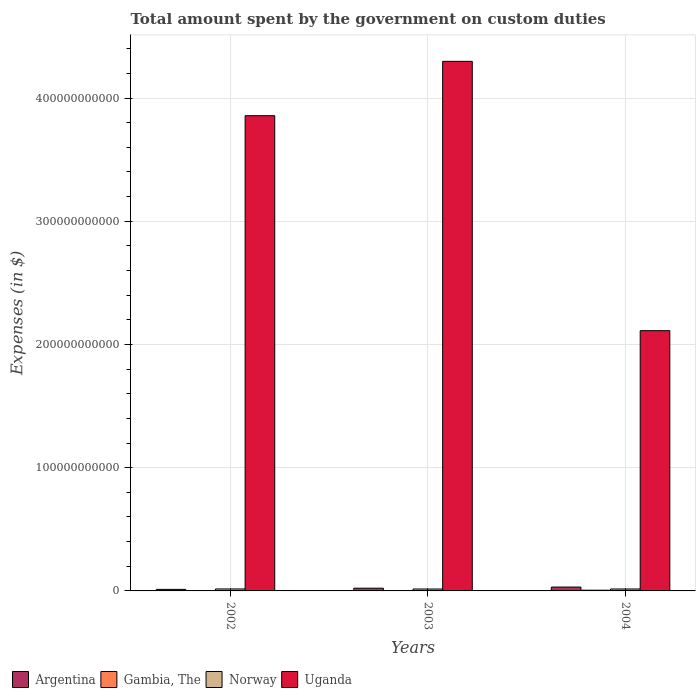How many groups of bars are there?
Your response must be concise. 3. Are the number of bars on each tick of the X-axis equal?
Your answer should be very brief. Yes. What is the amount spent on custom duties by the government in Uganda in 2002?
Ensure brevity in your answer.  3.86e+11. Across all years, what is the maximum amount spent on custom duties by the government in Gambia, The?
Your response must be concise. 5.77e+08. Across all years, what is the minimum amount spent on custom duties by the government in Uganda?
Offer a terse response. 2.11e+11. In which year was the amount spent on custom duties by the government in Gambia, The maximum?
Make the answer very short. 2004. In which year was the amount spent on custom duties by the government in Norway minimum?
Offer a terse response. 2003. What is the total amount spent on custom duties by the government in Gambia, The in the graph?
Give a very brief answer. 1.10e+09. What is the difference between the amount spent on custom duties by the government in Gambia, The in 2002 and that in 2004?
Provide a short and direct response. -3.51e+08. What is the difference between the amount spent on custom duties by the government in Norway in 2003 and the amount spent on custom duties by the government in Argentina in 2004?
Ensure brevity in your answer.  -1.58e+09. What is the average amount spent on custom duties by the government in Uganda per year?
Offer a very short reply. 3.42e+11. In the year 2002, what is the difference between the amount spent on custom duties by the government in Gambia, The and amount spent on custom duties by the government in Argentina?
Provide a short and direct response. -1.02e+09. In how many years, is the amount spent on custom duties by the government in Uganda greater than 160000000000 $?
Your answer should be very brief. 3. What is the ratio of the amount spent on custom duties by the government in Argentina in 2002 to that in 2004?
Your answer should be compact. 0.4. Is the amount spent on custom duties by the government in Uganda in 2003 less than that in 2004?
Keep it short and to the point. No. Is the difference between the amount spent on custom duties by the government in Gambia, The in 2003 and 2004 greater than the difference between the amount spent on custom duties by the government in Argentina in 2003 and 2004?
Offer a very short reply. Yes. What is the difference between the highest and the second highest amount spent on custom duties by the government in Gambia, The?
Keep it short and to the point. 2.86e+08. What is the difference between the highest and the lowest amount spent on custom duties by the government in Uganda?
Your answer should be compact. 2.19e+11. In how many years, is the amount spent on custom duties by the government in Norway greater than the average amount spent on custom duties by the government in Norway taken over all years?
Provide a short and direct response. 1. Is it the case that in every year, the sum of the amount spent on custom duties by the government in Gambia, The and amount spent on custom duties by the government in Uganda is greater than the sum of amount spent on custom duties by the government in Argentina and amount spent on custom duties by the government in Norway?
Provide a succinct answer. Yes. What does the 4th bar from the left in 2004 represents?
Keep it short and to the point. Uganda. What does the 1st bar from the right in 2002 represents?
Your answer should be very brief. Uganda. Is it the case that in every year, the sum of the amount spent on custom duties by the government in Gambia, The and amount spent on custom duties by the government in Argentina is greater than the amount spent on custom duties by the government in Norway?
Your answer should be very brief. No. How many bars are there?
Offer a terse response. 12. Are all the bars in the graph horizontal?
Keep it short and to the point. No. What is the difference between two consecutive major ticks on the Y-axis?
Give a very brief answer. 1.00e+11. Does the graph contain any zero values?
Make the answer very short. No. Does the graph contain grids?
Your response must be concise. Yes. How are the legend labels stacked?
Your answer should be compact. Horizontal. What is the title of the graph?
Your answer should be very brief. Total amount spent by the government on custom duties. Does "Bahamas" appear as one of the legend labels in the graph?
Your answer should be compact. No. What is the label or title of the Y-axis?
Offer a very short reply. Expenses (in $). What is the Expenses (in $) of Argentina in 2002?
Your answer should be compact. 1.25e+09. What is the Expenses (in $) in Gambia, The in 2002?
Give a very brief answer. 2.26e+08. What is the Expenses (in $) of Norway in 2002?
Your answer should be very brief. 1.61e+09. What is the Expenses (in $) of Uganda in 2002?
Offer a very short reply. 3.86e+11. What is the Expenses (in $) in Argentina in 2003?
Offer a very short reply. 2.21e+09. What is the Expenses (in $) of Gambia, The in 2003?
Your answer should be very brief. 2.92e+08. What is the Expenses (in $) of Norway in 2003?
Offer a terse response. 1.55e+09. What is the Expenses (in $) in Uganda in 2003?
Provide a short and direct response. 4.30e+11. What is the Expenses (in $) in Argentina in 2004?
Your response must be concise. 3.14e+09. What is the Expenses (in $) in Gambia, The in 2004?
Offer a very short reply. 5.77e+08. What is the Expenses (in $) in Norway in 2004?
Provide a short and direct response. 1.57e+09. What is the Expenses (in $) in Uganda in 2004?
Your response must be concise. 2.11e+11. Across all years, what is the maximum Expenses (in $) of Argentina?
Provide a succinct answer. 3.14e+09. Across all years, what is the maximum Expenses (in $) in Gambia, The?
Your response must be concise. 5.77e+08. Across all years, what is the maximum Expenses (in $) of Norway?
Ensure brevity in your answer.  1.61e+09. Across all years, what is the maximum Expenses (in $) of Uganda?
Provide a succinct answer. 4.30e+11. Across all years, what is the minimum Expenses (in $) in Argentina?
Ensure brevity in your answer.  1.25e+09. Across all years, what is the minimum Expenses (in $) in Gambia, The?
Your answer should be very brief. 2.26e+08. Across all years, what is the minimum Expenses (in $) in Norway?
Make the answer very short. 1.55e+09. Across all years, what is the minimum Expenses (in $) of Uganda?
Ensure brevity in your answer.  2.11e+11. What is the total Expenses (in $) of Argentina in the graph?
Provide a succinct answer. 6.59e+09. What is the total Expenses (in $) in Gambia, The in the graph?
Make the answer very short. 1.10e+09. What is the total Expenses (in $) of Norway in the graph?
Give a very brief answer. 4.73e+09. What is the total Expenses (in $) in Uganda in the graph?
Give a very brief answer. 1.03e+12. What is the difference between the Expenses (in $) of Argentina in 2002 and that in 2003?
Your response must be concise. -9.67e+08. What is the difference between the Expenses (in $) of Gambia, The in 2002 and that in 2003?
Make the answer very short. -6.56e+07. What is the difference between the Expenses (in $) in Norway in 2002 and that in 2003?
Offer a very short reply. 5.30e+07. What is the difference between the Expenses (in $) of Uganda in 2002 and that in 2003?
Your answer should be compact. -4.41e+1. What is the difference between the Expenses (in $) of Argentina in 2002 and that in 2004?
Provide a short and direct response. -1.89e+09. What is the difference between the Expenses (in $) of Gambia, The in 2002 and that in 2004?
Your answer should be very brief. -3.51e+08. What is the difference between the Expenses (in $) of Norway in 2002 and that in 2004?
Keep it short and to the point. 3.50e+07. What is the difference between the Expenses (in $) in Uganda in 2002 and that in 2004?
Offer a terse response. 1.74e+11. What is the difference between the Expenses (in $) in Argentina in 2003 and that in 2004?
Give a very brief answer. -9.25e+08. What is the difference between the Expenses (in $) in Gambia, The in 2003 and that in 2004?
Provide a succinct answer. -2.86e+08. What is the difference between the Expenses (in $) of Norway in 2003 and that in 2004?
Offer a very short reply. -1.80e+07. What is the difference between the Expenses (in $) in Uganda in 2003 and that in 2004?
Ensure brevity in your answer.  2.19e+11. What is the difference between the Expenses (in $) of Argentina in 2002 and the Expenses (in $) of Gambia, The in 2003?
Make the answer very short. 9.53e+08. What is the difference between the Expenses (in $) of Argentina in 2002 and the Expenses (in $) of Norway in 2003?
Your response must be concise. -3.09e+08. What is the difference between the Expenses (in $) of Argentina in 2002 and the Expenses (in $) of Uganda in 2003?
Your answer should be compact. -4.29e+11. What is the difference between the Expenses (in $) of Gambia, The in 2002 and the Expenses (in $) of Norway in 2003?
Provide a succinct answer. -1.33e+09. What is the difference between the Expenses (in $) in Gambia, The in 2002 and the Expenses (in $) in Uganda in 2003?
Ensure brevity in your answer.  -4.30e+11. What is the difference between the Expenses (in $) in Norway in 2002 and the Expenses (in $) in Uganda in 2003?
Ensure brevity in your answer.  -4.28e+11. What is the difference between the Expenses (in $) in Argentina in 2002 and the Expenses (in $) in Gambia, The in 2004?
Offer a terse response. 6.68e+08. What is the difference between the Expenses (in $) of Argentina in 2002 and the Expenses (in $) of Norway in 2004?
Your answer should be compact. -3.27e+08. What is the difference between the Expenses (in $) of Argentina in 2002 and the Expenses (in $) of Uganda in 2004?
Ensure brevity in your answer.  -2.10e+11. What is the difference between the Expenses (in $) of Gambia, The in 2002 and the Expenses (in $) of Norway in 2004?
Offer a terse response. -1.35e+09. What is the difference between the Expenses (in $) in Gambia, The in 2002 and the Expenses (in $) in Uganda in 2004?
Ensure brevity in your answer.  -2.11e+11. What is the difference between the Expenses (in $) in Norway in 2002 and the Expenses (in $) in Uganda in 2004?
Offer a terse response. -2.10e+11. What is the difference between the Expenses (in $) of Argentina in 2003 and the Expenses (in $) of Gambia, The in 2004?
Ensure brevity in your answer.  1.63e+09. What is the difference between the Expenses (in $) in Argentina in 2003 and the Expenses (in $) in Norway in 2004?
Offer a terse response. 6.40e+08. What is the difference between the Expenses (in $) of Argentina in 2003 and the Expenses (in $) of Uganda in 2004?
Your response must be concise. -2.09e+11. What is the difference between the Expenses (in $) of Gambia, The in 2003 and the Expenses (in $) of Norway in 2004?
Your response must be concise. -1.28e+09. What is the difference between the Expenses (in $) of Gambia, The in 2003 and the Expenses (in $) of Uganda in 2004?
Keep it short and to the point. -2.11e+11. What is the difference between the Expenses (in $) of Norway in 2003 and the Expenses (in $) of Uganda in 2004?
Make the answer very short. -2.10e+11. What is the average Expenses (in $) of Argentina per year?
Ensure brevity in your answer.  2.20e+09. What is the average Expenses (in $) of Gambia, The per year?
Provide a short and direct response. 3.65e+08. What is the average Expenses (in $) of Norway per year?
Give a very brief answer. 1.58e+09. What is the average Expenses (in $) in Uganda per year?
Your answer should be very brief. 3.42e+11. In the year 2002, what is the difference between the Expenses (in $) in Argentina and Expenses (in $) in Gambia, The?
Ensure brevity in your answer.  1.02e+09. In the year 2002, what is the difference between the Expenses (in $) of Argentina and Expenses (in $) of Norway?
Your answer should be compact. -3.62e+08. In the year 2002, what is the difference between the Expenses (in $) in Argentina and Expenses (in $) in Uganda?
Keep it short and to the point. -3.84e+11. In the year 2002, what is the difference between the Expenses (in $) in Gambia, The and Expenses (in $) in Norway?
Make the answer very short. -1.38e+09. In the year 2002, what is the difference between the Expenses (in $) of Gambia, The and Expenses (in $) of Uganda?
Give a very brief answer. -3.85e+11. In the year 2002, what is the difference between the Expenses (in $) in Norway and Expenses (in $) in Uganda?
Your answer should be very brief. -3.84e+11. In the year 2003, what is the difference between the Expenses (in $) of Argentina and Expenses (in $) of Gambia, The?
Make the answer very short. 1.92e+09. In the year 2003, what is the difference between the Expenses (in $) of Argentina and Expenses (in $) of Norway?
Your response must be concise. 6.58e+08. In the year 2003, what is the difference between the Expenses (in $) in Argentina and Expenses (in $) in Uganda?
Keep it short and to the point. -4.28e+11. In the year 2003, what is the difference between the Expenses (in $) of Gambia, The and Expenses (in $) of Norway?
Your response must be concise. -1.26e+09. In the year 2003, what is the difference between the Expenses (in $) in Gambia, The and Expenses (in $) in Uganda?
Provide a short and direct response. -4.29e+11. In the year 2003, what is the difference between the Expenses (in $) in Norway and Expenses (in $) in Uganda?
Keep it short and to the point. -4.28e+11. In the year 2004, what is the difference between the Expenses (in $) of Argentina and Expenses (in $) of Gambia, The?
Give a very brief answer. 2.56e+09. In the year 2004, what is the difference between the Expenses (in $) in Argentina and Expenses (in $) in Norway?
Your answer should be compact. 1.57e+09. In the year 2004, what is the difference between the Expenses (in $) in Argentina and Expenses (in $) in Uganda?
Your answer should be compact. -2.08e+11. In the year 2004, what is the difference between the Expenses (in $) in Gambia, The and Expenses (in $) in Norway?
Give a very brief answer. -9.95e+08. In the year 2004, what is the difference between the Expenses (in $) of Gambia, The and Expenses (in $) of Uganda?
Your answer should be very brief. -2.11e+11. In the year 2004, what is the difference between the Expenses (in $) of Norway and Expenses (in $) of Uganda?
Your answer should be very brief. -2.10e+11. What is the ratio of the Expenses (in $) of Argentina in 2002 to that in 2003?
Your answer should be compact. 0.56. What is the ratio of the Expenses (in $) of Gambia, The in 2002 to that in 2003?
Your answer should be very brief. 0.78. What is the ratio of the Expenses (in $) in Norway in 2002 to that in 2003?
Your answer should be compact. 1.03. What is the ratio of the Expenses (in $) of Uganda in 2002 to that in 2003?
Offer a terse response. 0.9. What is the ratio of the Expenses (in $) of Argentina in 2002 to that in 2004?
Ensure brevity in your answer.  0.4. What is the ratio of the Expenses (in $) in Gambia, The in 2002 to that in 2004?
Offer a terse response. 0.39. What is the ratio of the Expenses (in $) of Norway in 2002 to that in 2004?
Your response must be concise. 1.02. What is the ratio of the Expenses (in $) of Uganda in 2002 to that in 2004?
Offer a very short reply. 1.83. What is the ratio of the Expenses (in $) of Argentina in 2003 to that in 2004?
Offer a terse response. 0.71. What is the ratio of the Expenses (in $) in Gambia, The in 2003 to that in 2004?
Give a very brief answer. 0.51. What is the ratio of the Expenses (in $) of Norway in 2003 to that in 2004?
Keep it short and to the point. 0.99. What is the ratio of the Expenses (in $) of Uganda in 2003 to that in 2004?
Your response must be concise. 2.03. What is the difference between the highest and the second highest Expenses (in $) of Argentina?
Your answer should be compact. 9.25e+08. What is the difference between the highest and the second highest Expenses (in $) in Gambia, The?
Your answer should be very brief. 2.86e+08. What is the difference between the highest and the second highest Expenses (in $) of Norway?
Provide a succinct answer. 3.50e+07. What is the difference between the highest and the second highest Expenses (in $) of Uganda?
Give a very brief answer. 4.41e+1. What is the difference between the highest and the lowest Expenses (in $) of Argentina?
Your answer should be compact. 1.89e+09. What is the difference between the highest and the lowest Expenses (in $) of Gambia, The?
Make the answer very short. 3.51e+08. What is the difference between the highest and the lowest Expenses (in $) in Norway?
Offer a terse response. 5.30e+07. What is the difference between the highest and the lowest Expenses (in $) of Uganda?
Your answer should be very brief. 2.19e+11. 